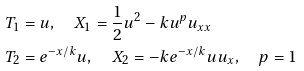<formula> <loc_0><loc_0><loc_500><loc_500>& T _ { 1 } = u , \quad X _ { 1 } = \frac { 1 } { 2 } u ^ { 2 } - k u ^ { p } u _ { x x } \\ & T _ { 2 } = e ^ { - x / k } u , \quad X _ { 2 } = - k e ^ { - x / k } u u _ { x } , \quad p = 1</formula> 